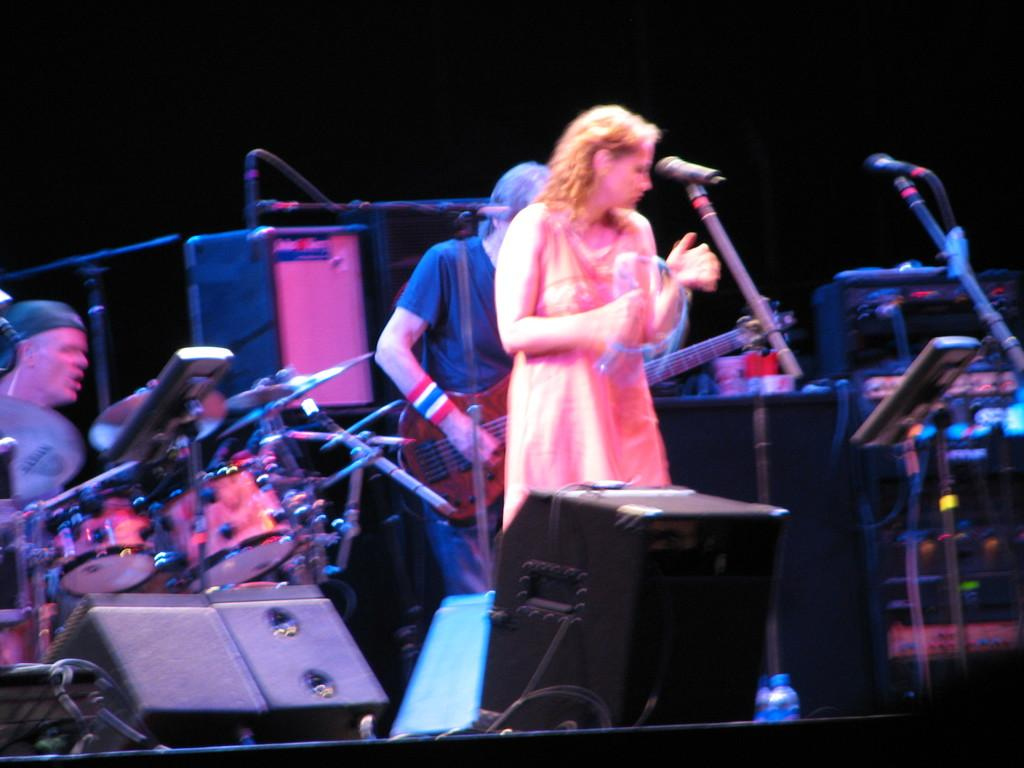How many persons are playing musical instruments in the image? There are three persons playing musical instruments in the image. What else can be seen in the image besides the persons playing instruments? There are mice and black color objects in the image. Can you describe the object that resembles a speaker? Yes, it looks like a speaker, typically used for amplifying sound. What is the color of the background in the image? The background of the image is dark. What type of bird can be seen interacting with the brass objects in the image? There are no birds or brass objects present in the image; it features three persons playing musical instruments, mice, and an object that resembles a speaker. How many marks can be seen on the black color objects in the image? There are no marks visible on the black color objects in the image. 